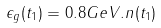Convert formula to latex. <formula><loc_0><loc_0><loc_500><loc_500>\epsilon _ { g } ( t _ { 1 } ) = 0 . 8 G e V . n ( t _ { 1 } )</formula> 